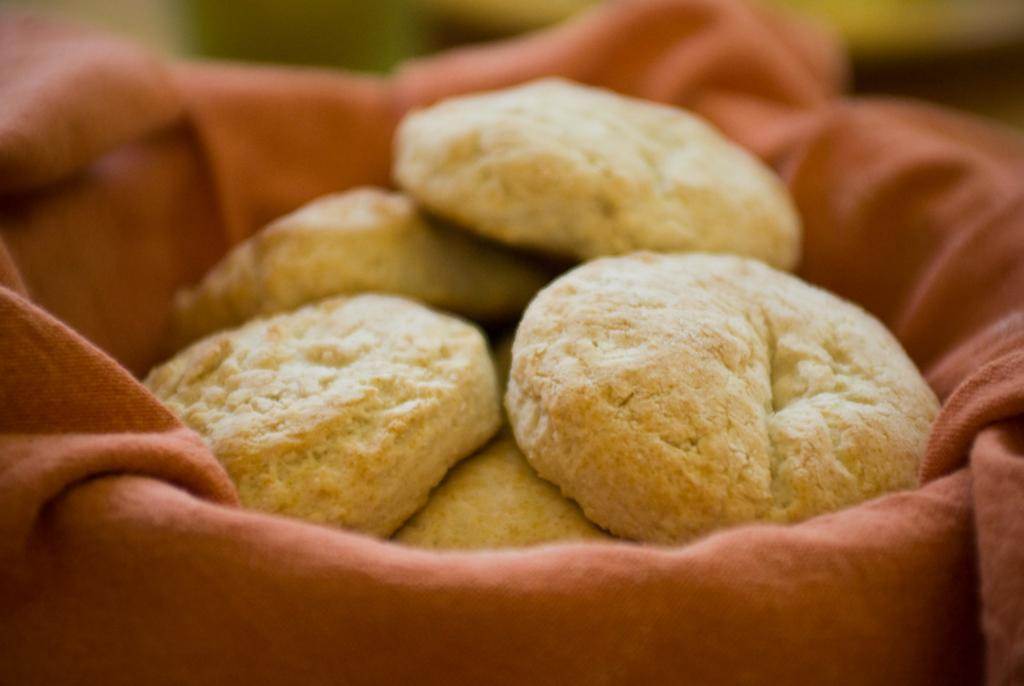What type of food can be seen in the image? There are cookies in the image. What material is present in the image? There is cloth in the image. How would you describe the background of the image? The background of the image is blurry. Can you see any signs of a fight between the sea and the authority in the image? There is no reference to a fight, the sea, or any authority figures in the image. 